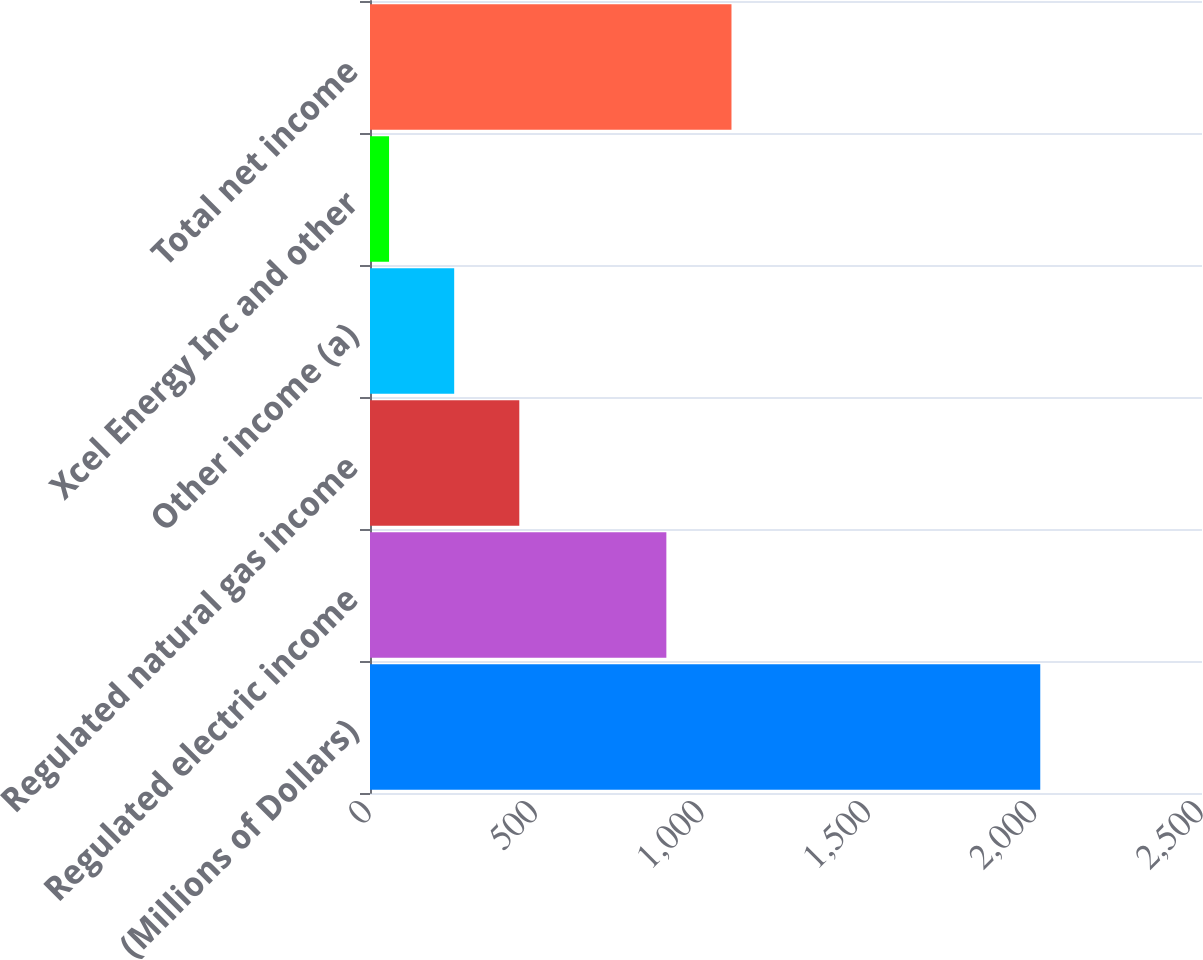<chart> <loc_0><loc_0><loc_500><loc_500><bar_chart><fcel>(Millions of Dollars)<fcel>Regulated electric income<fcel>Regulated natural gas income<fcel>Other income (a)<fcel>Xcel Energy Inc and other<fcel>Total net income<nl><fcel>2014<fcel>890.5<fcel>448.64<fcel>252.97<fcel>57.3<fcel>1086.17<nl></chart> 